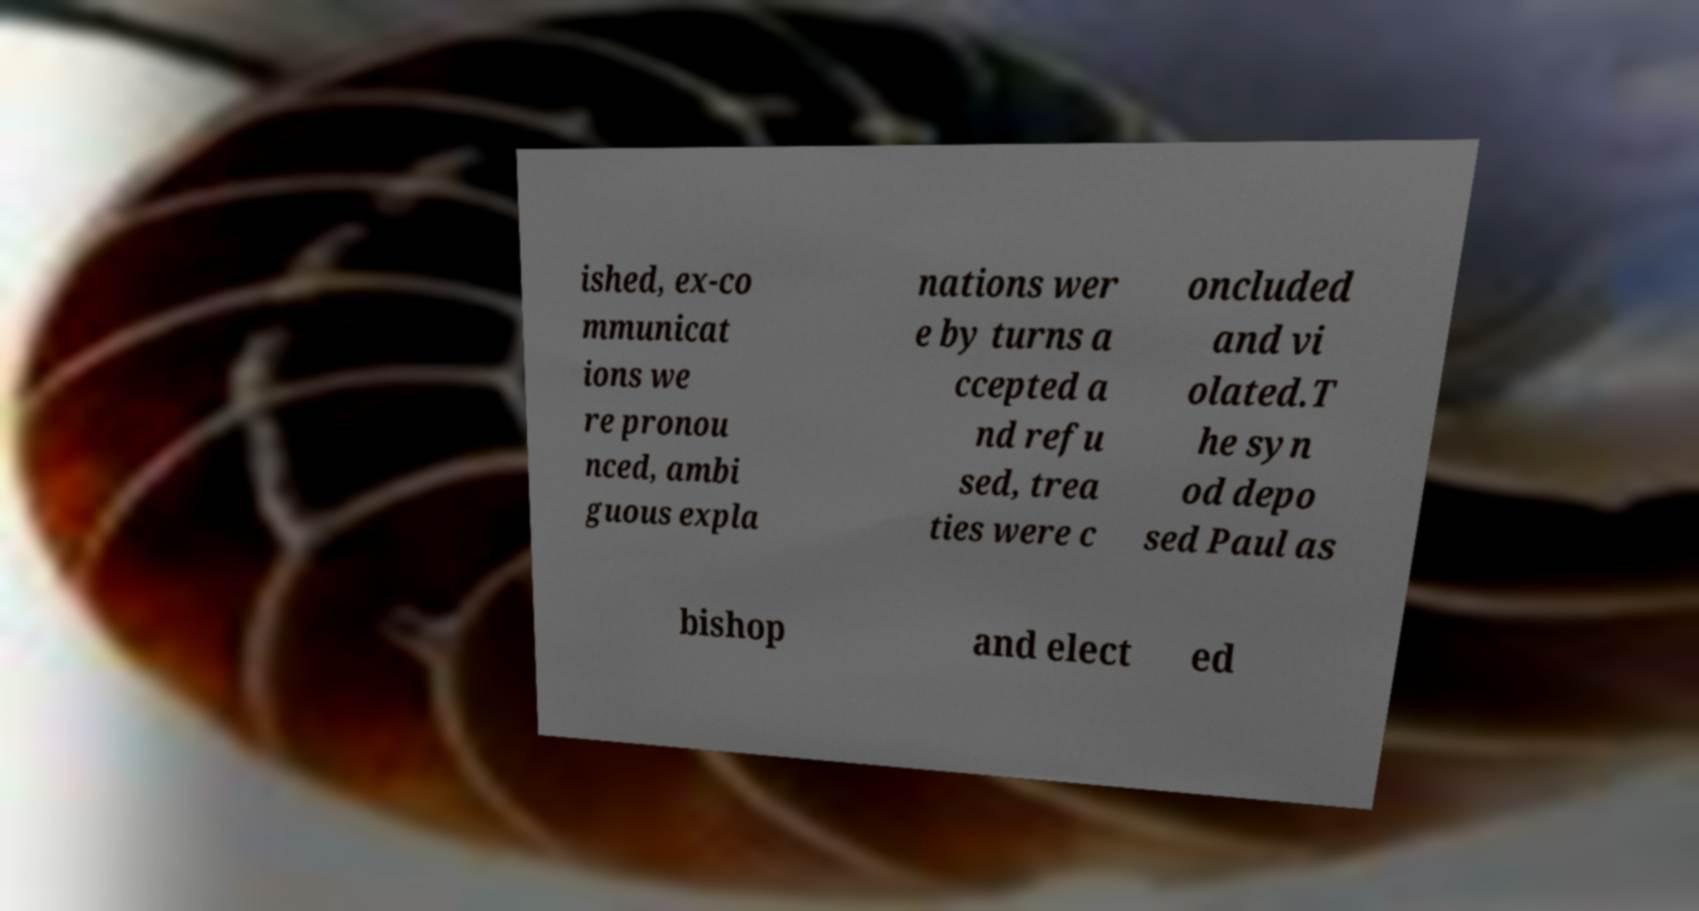Please identify and transcribe the text found in this image. ished, ex-co mmunicat ions we re pronou nced, ambi guous expla nations wer e by turns a ccepted a nd refu sed, trea ties were c oncluded and vi olated.T he syn od depo sed Paul as bishop and elect ed 